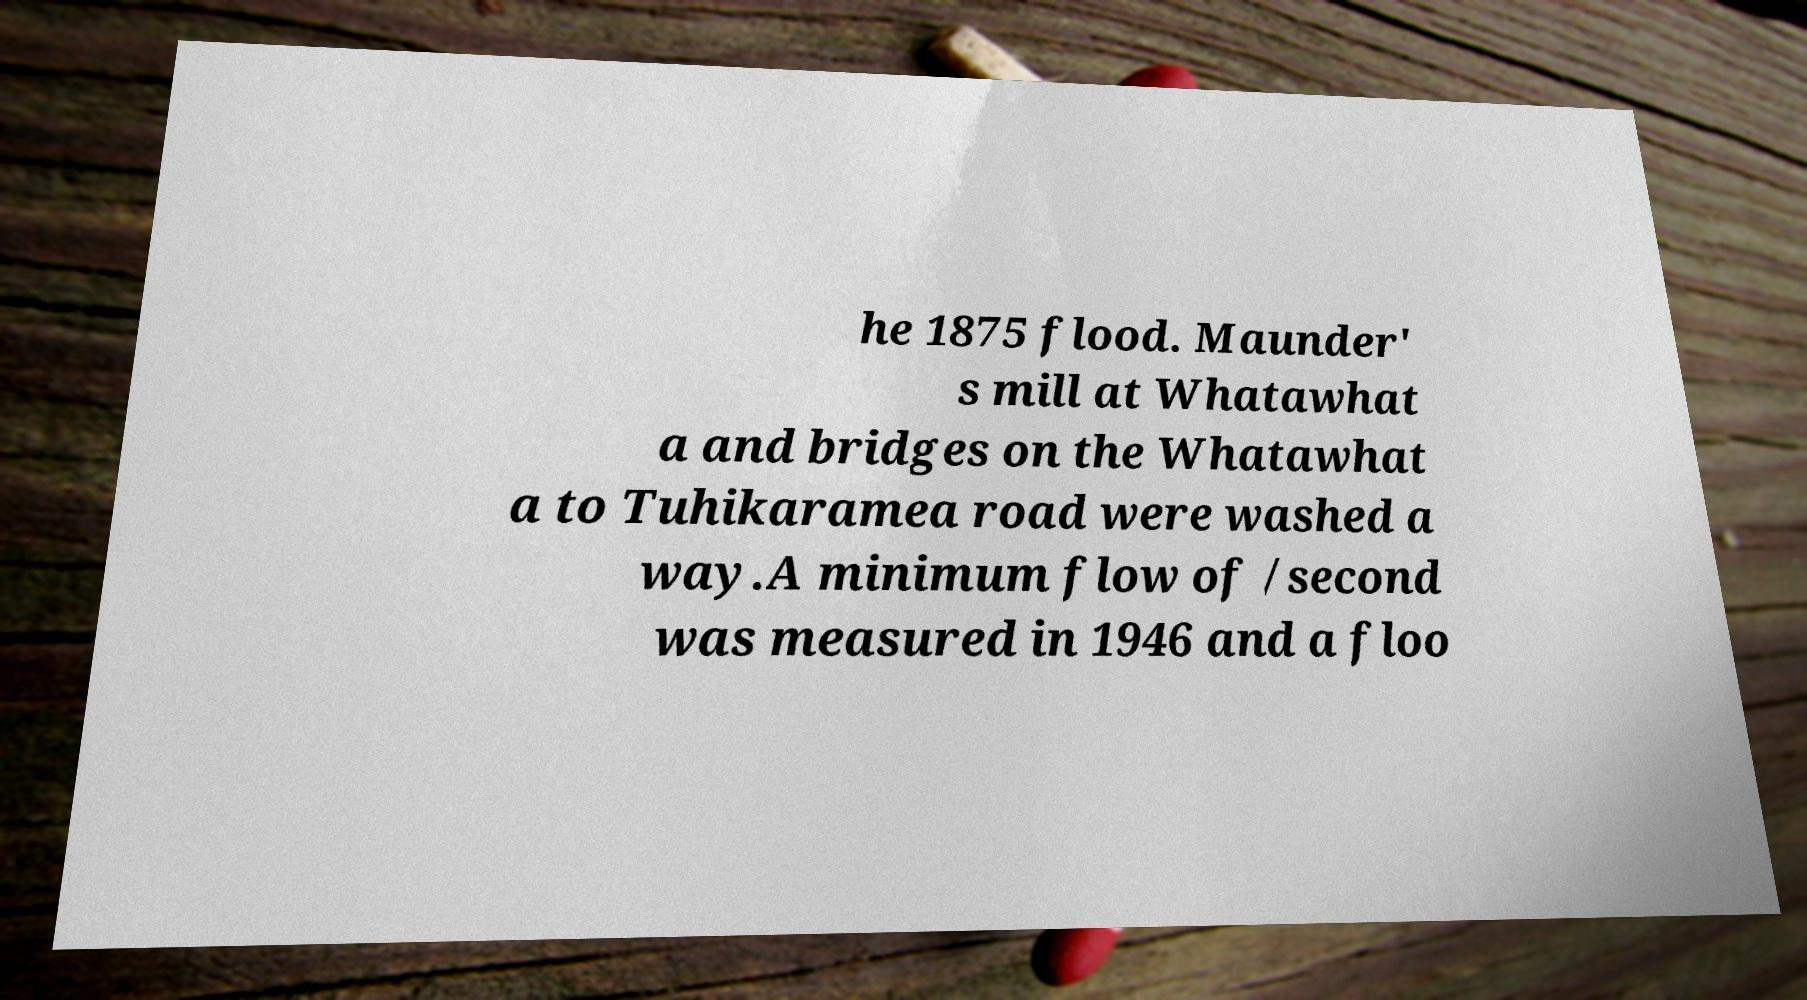Could you assist in decoding the text presented in this image and type it out clearly? he 1875 flood. Maunder' s mill at Whatawhat a and bridges on the Whatawhat a to Tuhikaramea road were washed a way.A minimum flow of /second was measured in 1946 and a floo 